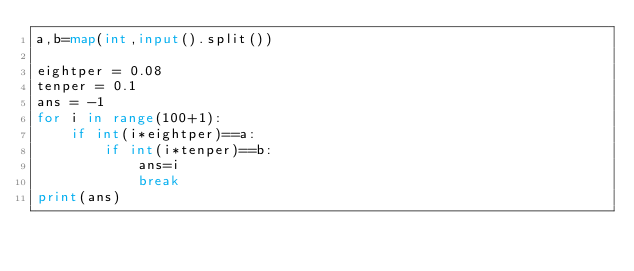<code> <loc_0><loc_0><loc_500><loc_500><_Python_>a,b=map(int,input().split())

eightper = 0.08
tenper = 0.1
ans = -1
for i in range(100+1):
    if int(i*eightper)==a:
        if int(i*tenper)==b:
            ans=i
            break
print(ans)</code> 